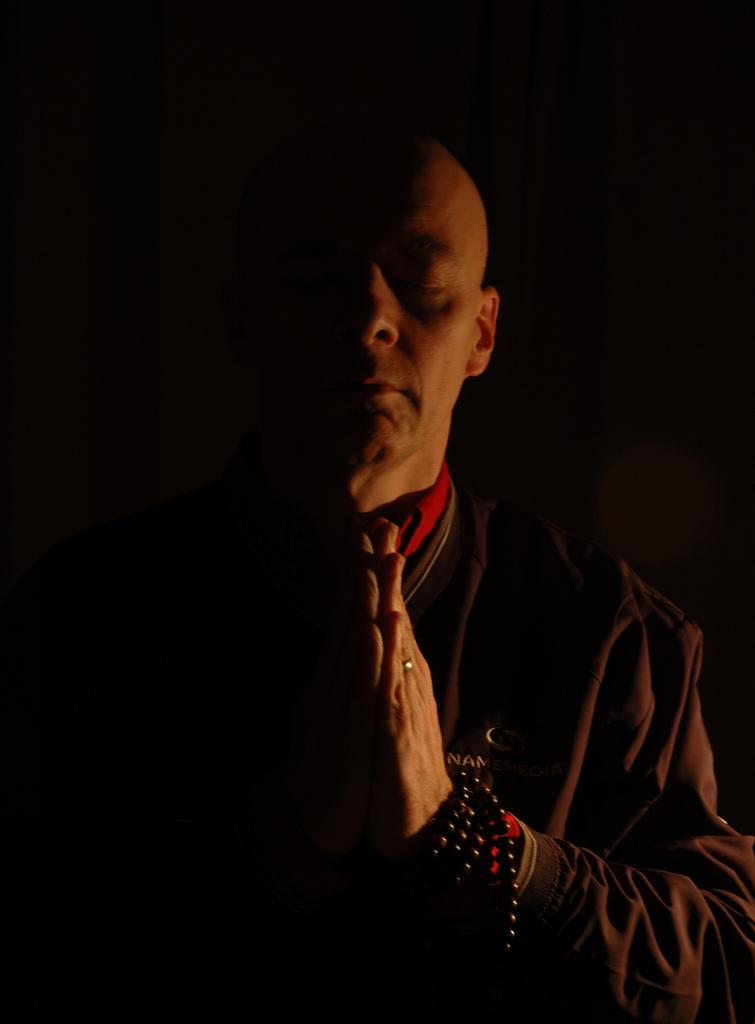Who is the main subject in the image? There is a man in the picture. What is the man doing in the image? The man is standing. What is the man wearing in the image? The man is wearing a brown coat. What is the man doing with his hands in the image? The man is holding his hands together. What can be seen in the background of the image? The backdrop of the image is dark. What type of tree can be seen growing out of the drawer in the image? There is no drawer or tree present in the image. 